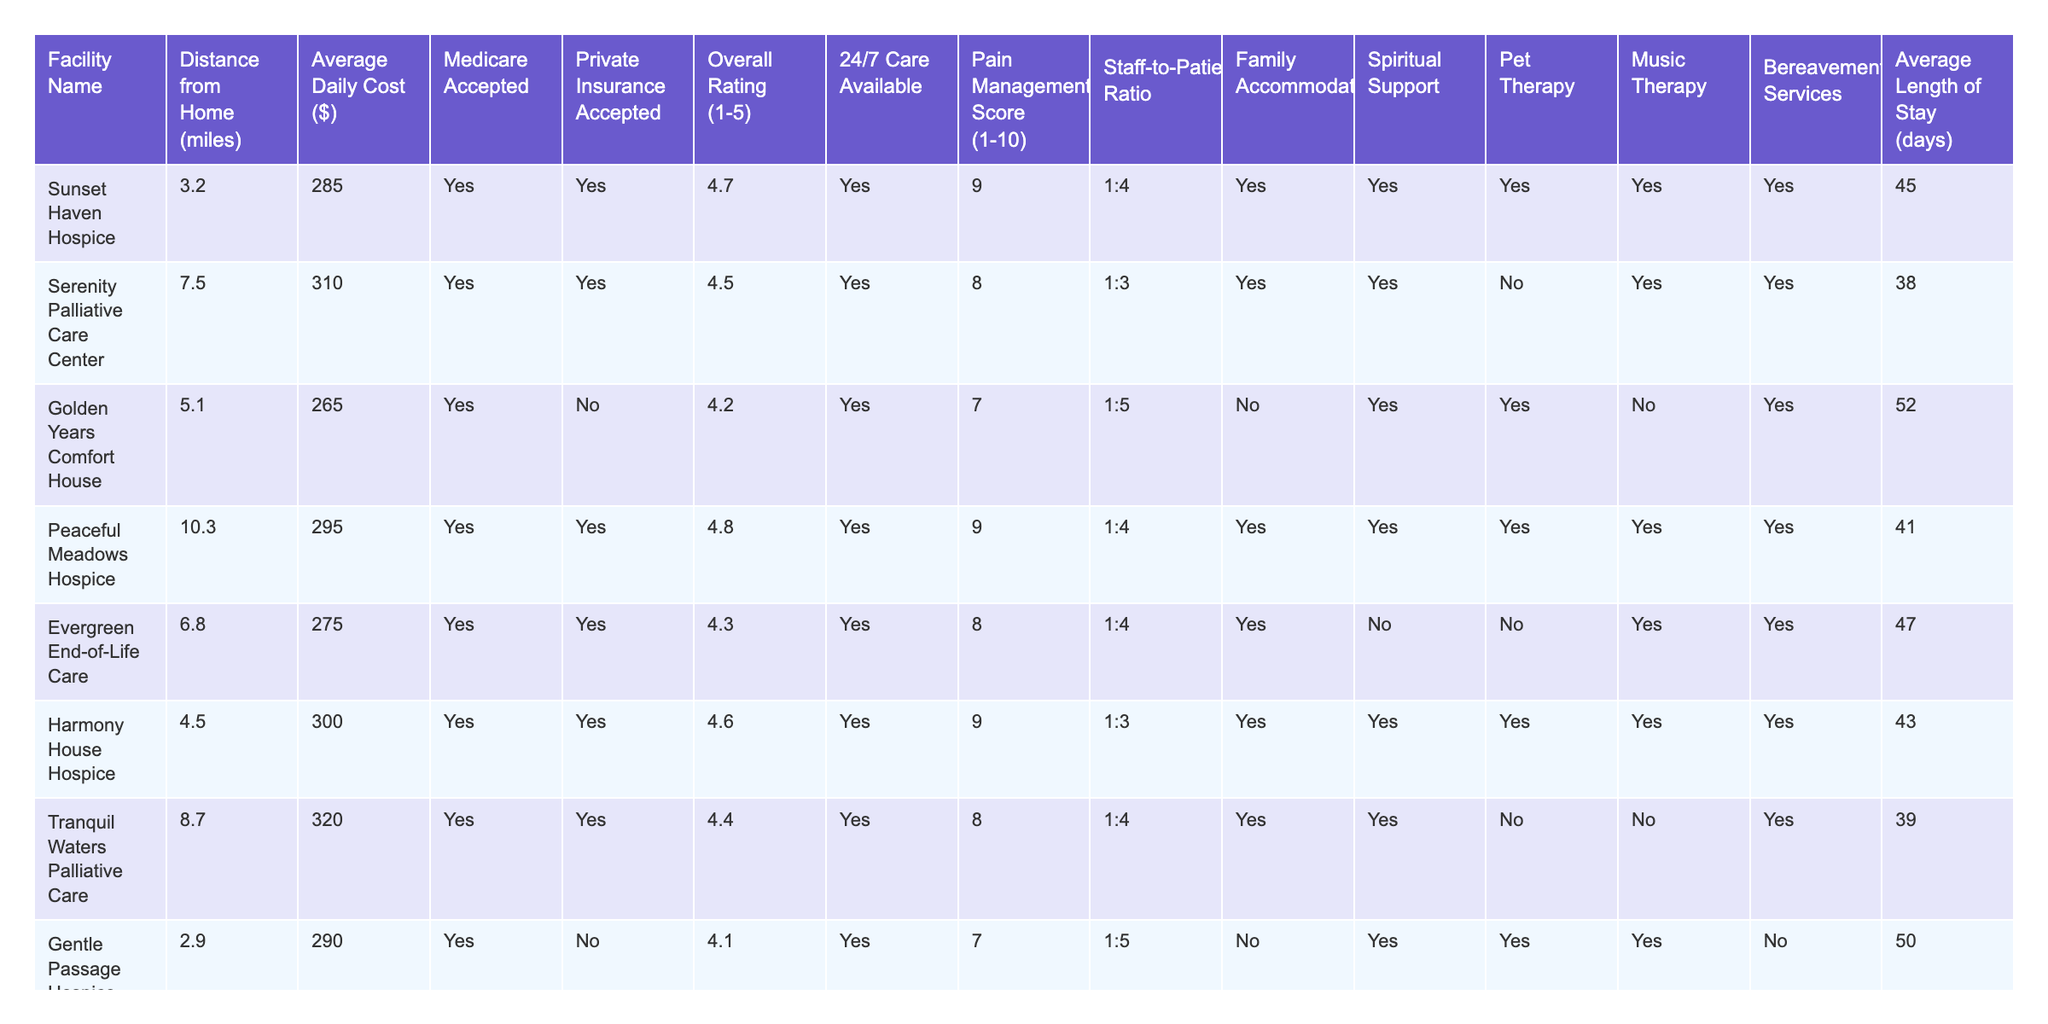What is the hospice facility with the highest overall rating? By looking at the Overall Rating column, we can identify that Sunset Haven Hospice has the highest rating of 4.7.
Answer: Sunset Haven Hospice How many facilities accept private insurance? By counting the "Yes" entries under the Private Insurance Accepted column, we find that there are 6 facilities that accept private insurance.
Answer: 6 What is the average daily cost of hospice care in the local area? Adding the average daily costs ($285 + $310 + $265 + $295 + $275 + $300 + $320 + $290 + $280 + $305) gives us a total of $2,855. Dividing by the number of facilities (10) results in an average of $285.50 for the daily cost.
Answer: $285.50 Which facility is the closest to home? Looking at the Distance from Home column, Gentle Passage Hospice Center is the closest at 2.9 miles.
Answer: Gentle Passage Hospice Center Is there a hospice facility that provides both pet therapy and music therapy? We check the Pet Therapy and Music Therapy columns. Harmony House Hospice is the only facility that offers both services.
Answer: Yes What is the staff-to-patient ratio at Peaceful Meadows Hospice? The Staff-to-Patient Ratio column indicates that Peaceful Meadows Hospice has a ratio of 1:4.
Answer: 1:4 Which facility has the longest average length of stay? By examining the Average Length of Stay column, we can see that Golden Years Comfort House has the longest average length of stay at 52 days.
Answer: Golden Years Comfort House What is the difference in average daily cost between the most expensive and least expensive facilities? The most expensive facility is Tranquil Waters Palliative Care at $320, and the least expensive is Golden Years Comfort House at $265. The difference is $320 - $265 = $55.
Answer: $55 How many facilities provide bereavement services? Looking at the Bereavement Services column, we find that 7 out of the 10 facilities offer bereavement services.
Answer: 7 Is Sunset Haven Hospice the only facility with a pain management score of 9? We need to check the Pain Management Score column. Sunset Haven Hospice and Peaceful Meadows Hospice both have a score of 9, so it is not the only one.
Answer: No 